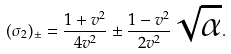<formula> <loc_0><loc_0><loc_500><loc_500>( \sigma _ { 2 } ) _ { \pm } = \frac { 1 + v ^ { 2 } } { 4 v ^ { 2 } } \pm \frac { 1 - v ^ { 2 } } { 2 v ^ { 2 } } \sqrt { \alpha } .</formula> 